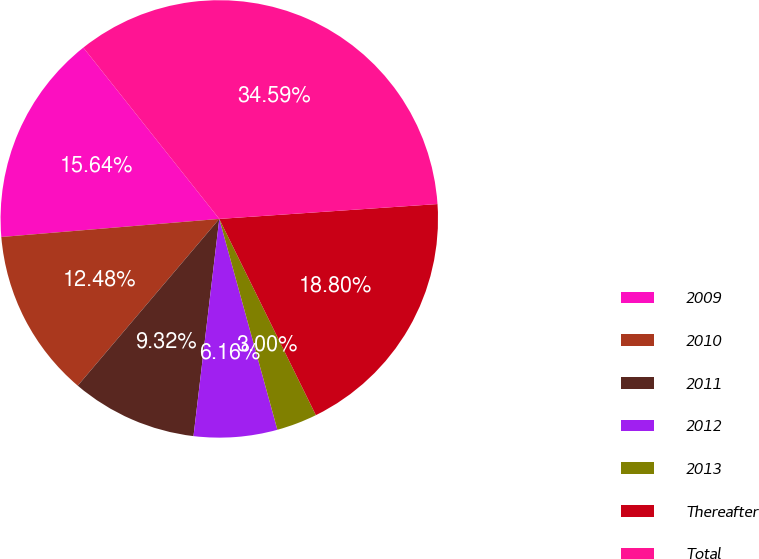<chart> <loc_0><loc_0><loc_500><loc_500><pie_chart><fcel>2009<fcel>2010<fcel>2011<fcel>2012<fcel>2013<fcel>Thereafter<fcel>Total<nl><fcel>15.64%<fcel>12.48%<fcel>9.32%<fcel>6.16%<fcel>3.0%<fcel>18.8%<fcel>34.59%<nl></chart> 